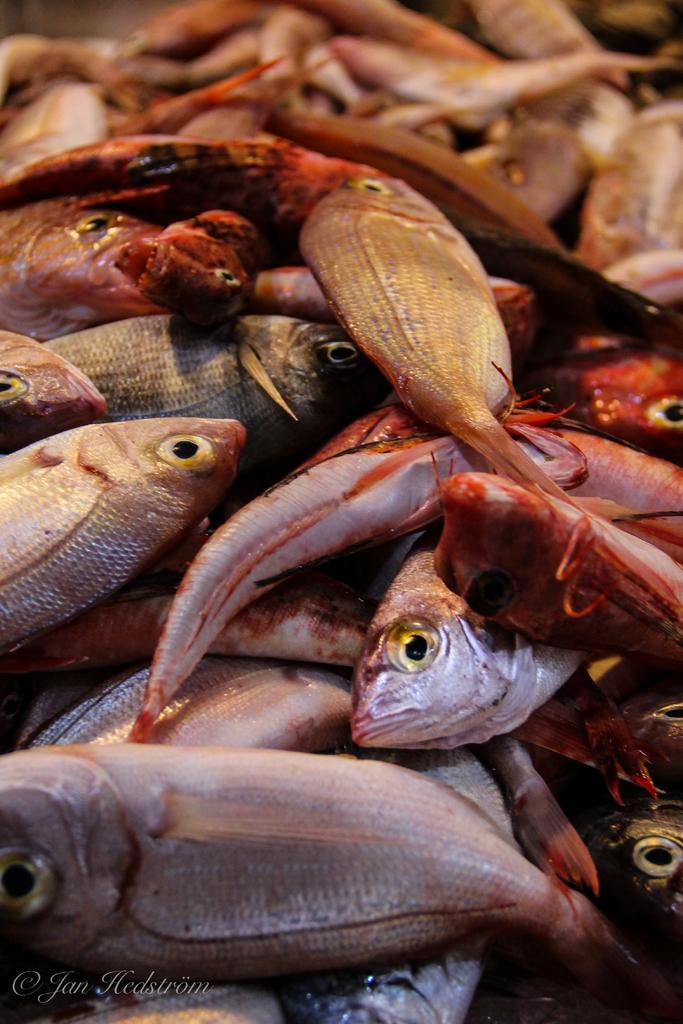What type of animals can be seen in the image? There are fish in the image. Where is the text located in the image? The text is in the bottom left side of the image. What type of knee injury is depicted in the image? There is no knee injury present in the image; it features fish and text. How many times does the attack occur in the image? There is no attack depicted in the image; it features fish and text. 